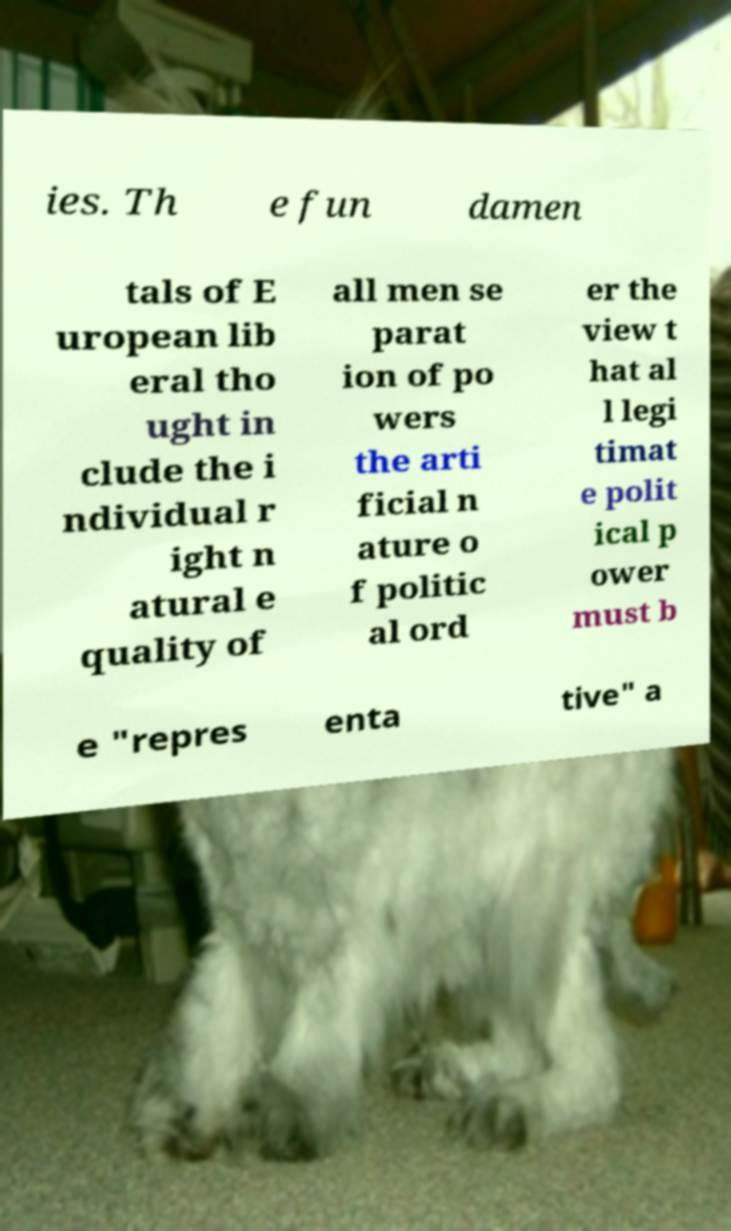Please identify and transcribe the text found in this image. ies. Th e fun damen tals of E uropean lib eral tho ught in clude the i ndividual r ight n atural e quality of all men se parat ion of po wers the arti ficial n ature o f politic al ord er the view t hat al l legi timat e polit ical p ower must b e "repres enta tive" a 